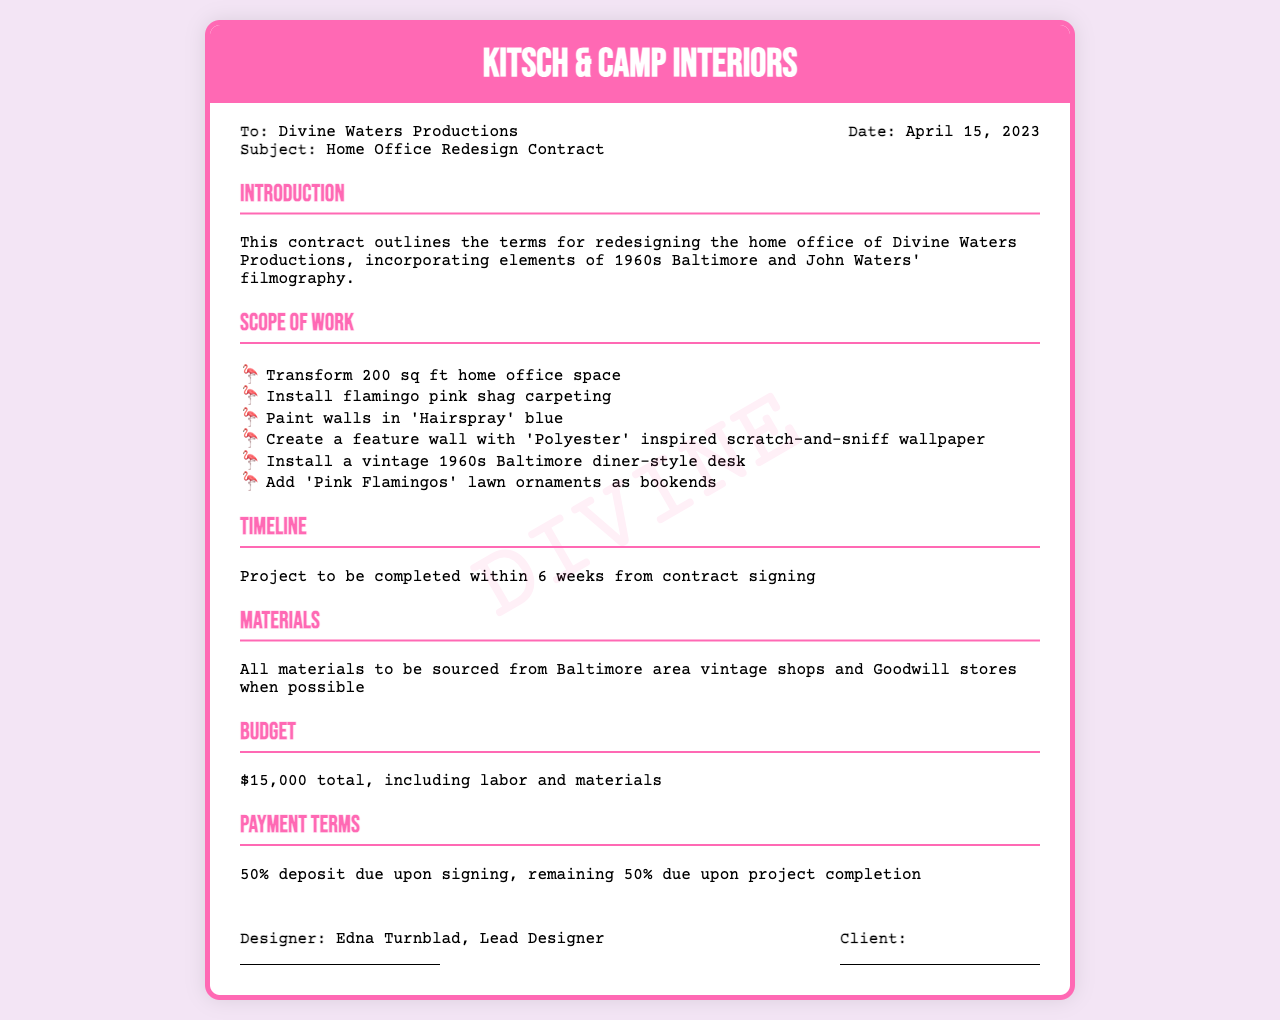What is the project budget? The budget for the project, as stated in the document, is $15,000 total.
Answer: $15,000 Who is the lead designer? The document specifies Edna Turnblad as the lead designer for the project.
Answer: Edna Turnblad What is the total square footage of the home office space? The document mentions the home office space transformation is for a 200 sq ft area.
Answer: 200 sq ft When was the contract signed? The date mentioned in the document for the contract is April 15, 2023.
Answer: April 15, 2023 What is one unique wall treatment mentioned in the scope? The document includes 'Polyester' inspired scratch-and-sniff wallpaper as a unique wall treatment for the office.
Answer: 'Polyester' inspired scratch-and-sniff wallpaper What percentage is the deposit required? According to the payment terms, a 50% deposit is required upon signing the contract.
Answer: 50% What is the expected timeline for completion? The document states that the project is to be completed within 6 weeks from the signing of the contract.
Answer: 6 weeks Where will materials be sourced from? The document specifies that all materials will be sourced from Baltimore area vintage shops and Goodwill stores when possible.
Answer: Baltimore area vintage shops and Goodwill stores What type of carpeting is mentioned? The document specifies that flamingo pink shag carpeting will be installed.
Answer: flamingo pink shag carpeting 